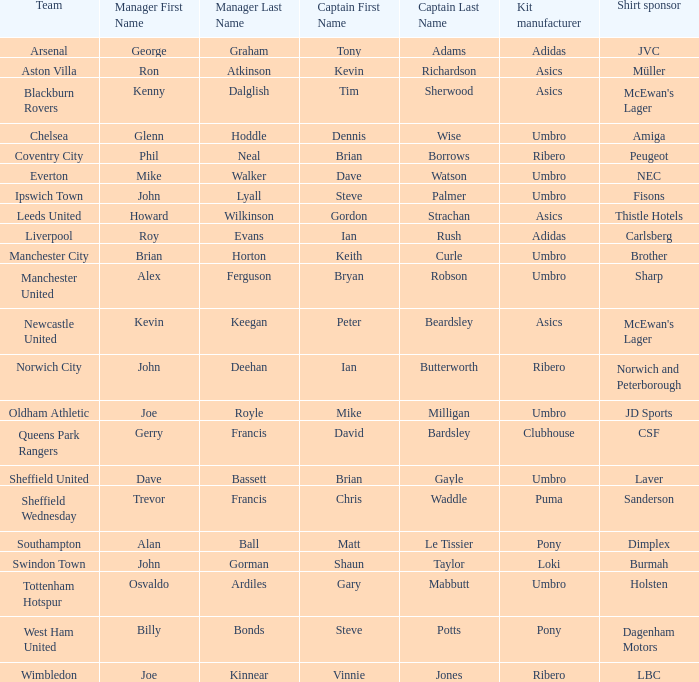Which captain has howard wilkinson as the manager? Gordon Strachan. 